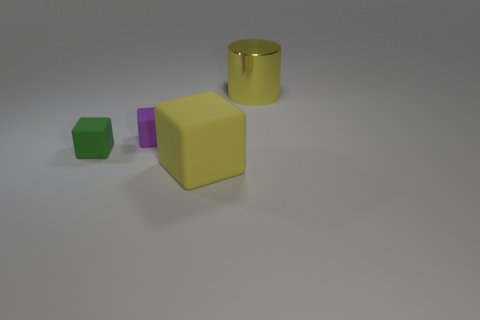Add 4 blue rubber cylinders. How many objects exist? 8 Subtract all blocks. How many objects are left? 1 Subtract all big yellow rubber cylinders. Subtract all big metallic things. How many objects are left? 3 Add 4 purple rubber cubes. How many purple rubber cubes are left? 5 Add 2 red matte spheres. How many red matte spheres exist? 2 Subtract 0 brown spheres. How many objects are left? 4 